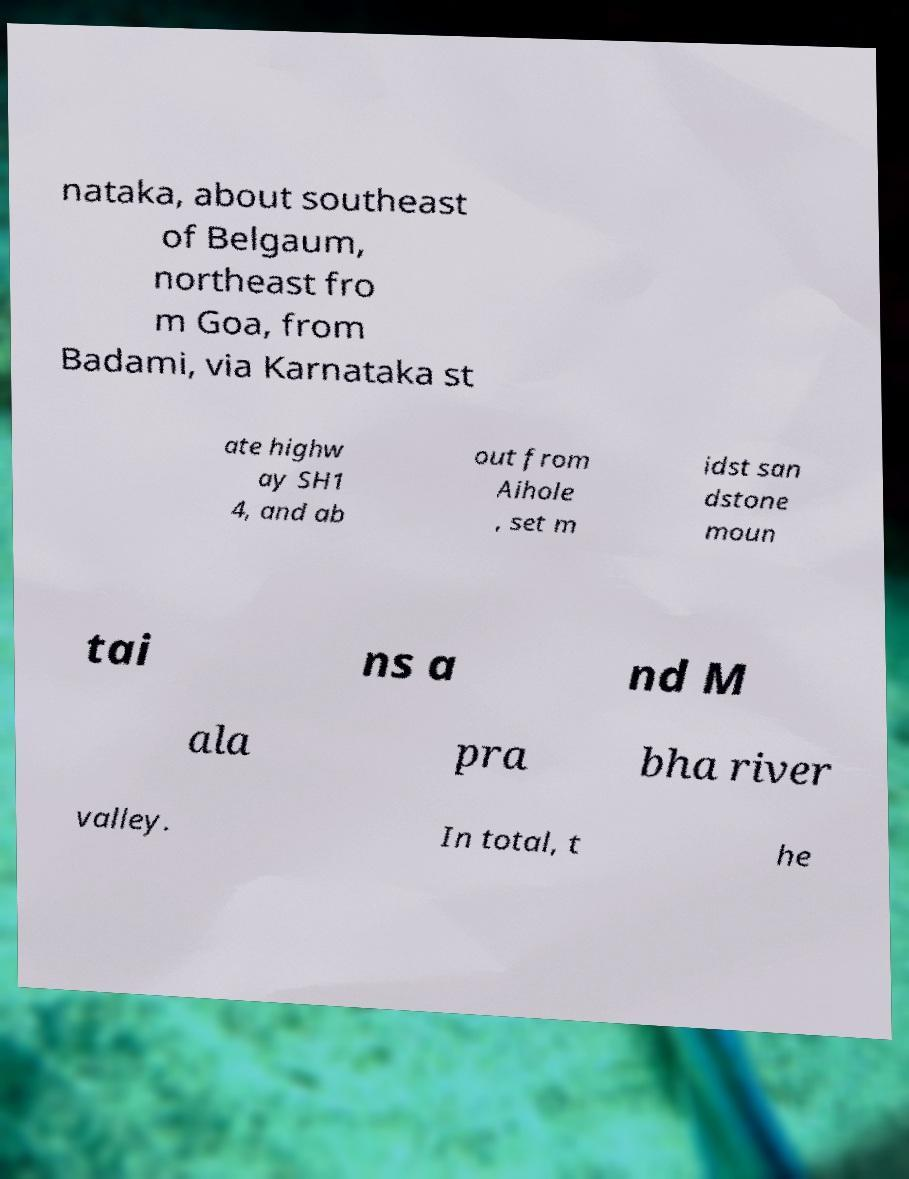What messages or text are displayed in this image? I need them in a readable, typed format. nataka, about southeast of Belgaum, northeast fro m Goa, from Badami, via Karnataka st ate highw ay SH1 4, and ab out from Aihole , set m idst san dstone moun tai ns a nd M ala pra bha river valley. In total, t he 